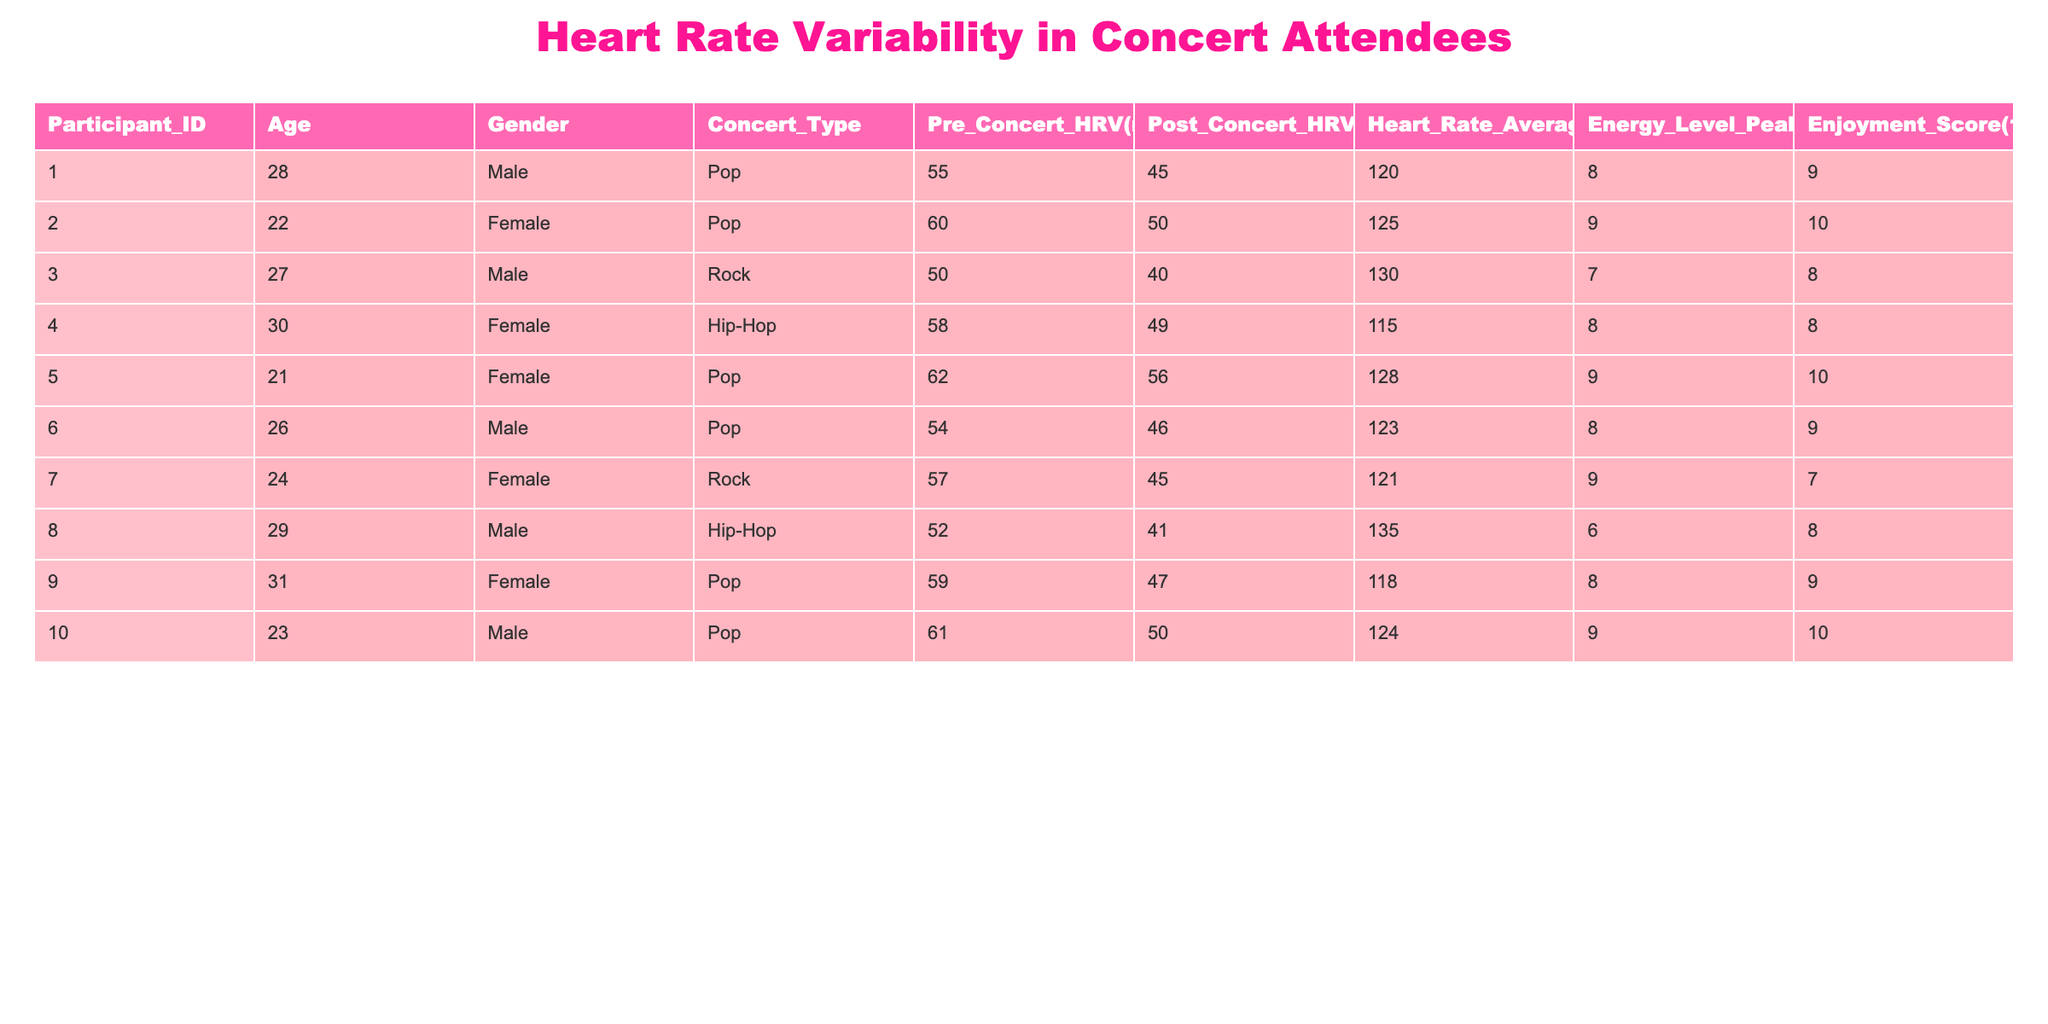What is the Post Concert HRV for Participant 2? Look at the row corresponding to Participant 2 in the Post Concert HRV column. The value listed is 50 ms.
Answer: 50 ms What was the average heart rate for all participants? To find the average heart rate, sum up all the heart rates: 120 + 125 + 130 + 115 + 128 + 123 + 121 + 135 + 118 + 124 = 1254. There are 10 participants, so the average heart rate is 1254/10 = 125.4 bpm.
Answer: 125.4 bpm Is there any participant whose Post Concert HRV is greater than their Pre Concert HRV? We compare the Post Concert HRV values with Pre Concert HRV values for each participant. Participant 5 has Pre Concert HRV of 62 ms and Post Concert HRV of 56 ms, which is lower. No other participants have Post Concert HRV greater than Pre Concert HRV, confirming the answer is no.
Answer: No Which concert type had the highest average Enjoyment Score? We calculate the average Enjoyment Score for each concert type: 
- For Pop: (9 + 10 + 10 + 9 + 10)/5 = 9.6
- For Rock: (8 + 7)/2 = 7.5
- For Hip-Hop: (8 + 8)/2 = 8.0
Pop has the highest average Enjoyment Score at 9.6.
Answer: Pop How many participants had an Energy Level Peak of 9 or higher? We will count the number of participants with an Energy Level Peak of 9 or higher. The participants with Energy Level Peak of 9 are Participants 2, 5, 6, 10 (four participants).
Answer: 4 What was the difference in Pre Concert HRV between the youngest and oldest participants? The youngest participant is Participant 5, with a Pre Concert HRV of 62 ms, and the oldest participant is Participant 9, with a Pre Concert HRV of 59 ms. The difference is 62 - 59 = 3 ms.
Answer: 3 ms 